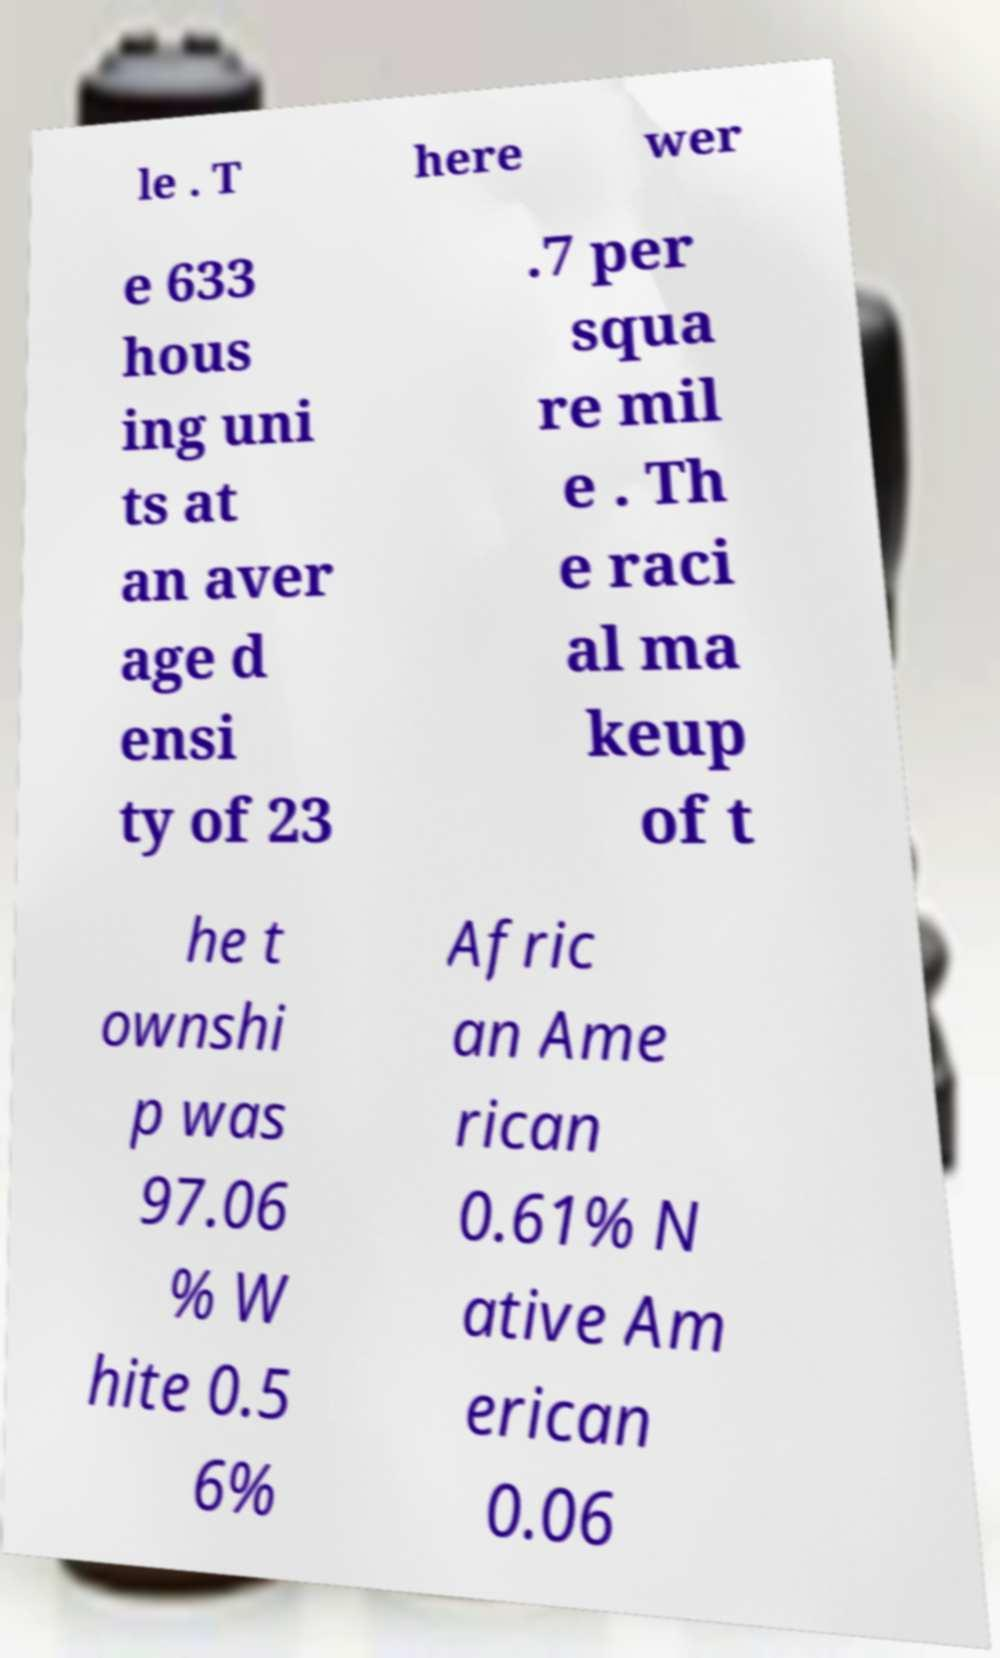Can you read and provide the text displayed in the image?This photo seems to have some interesting text. Can you extract and type it out for me? le . T here wer e 633 hous ing uni ts at an aver age d ensi ty of 23 .7 per squa re mil e . Th e raci al ma keup of t he t ownshi p was 97.06 % W hite 0.5 6% Afric an Ame rican 0.61% N ative Am erican 0.06 